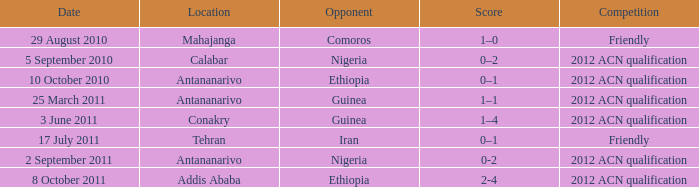What is the score at the Addis Ababa location? 2-4. 